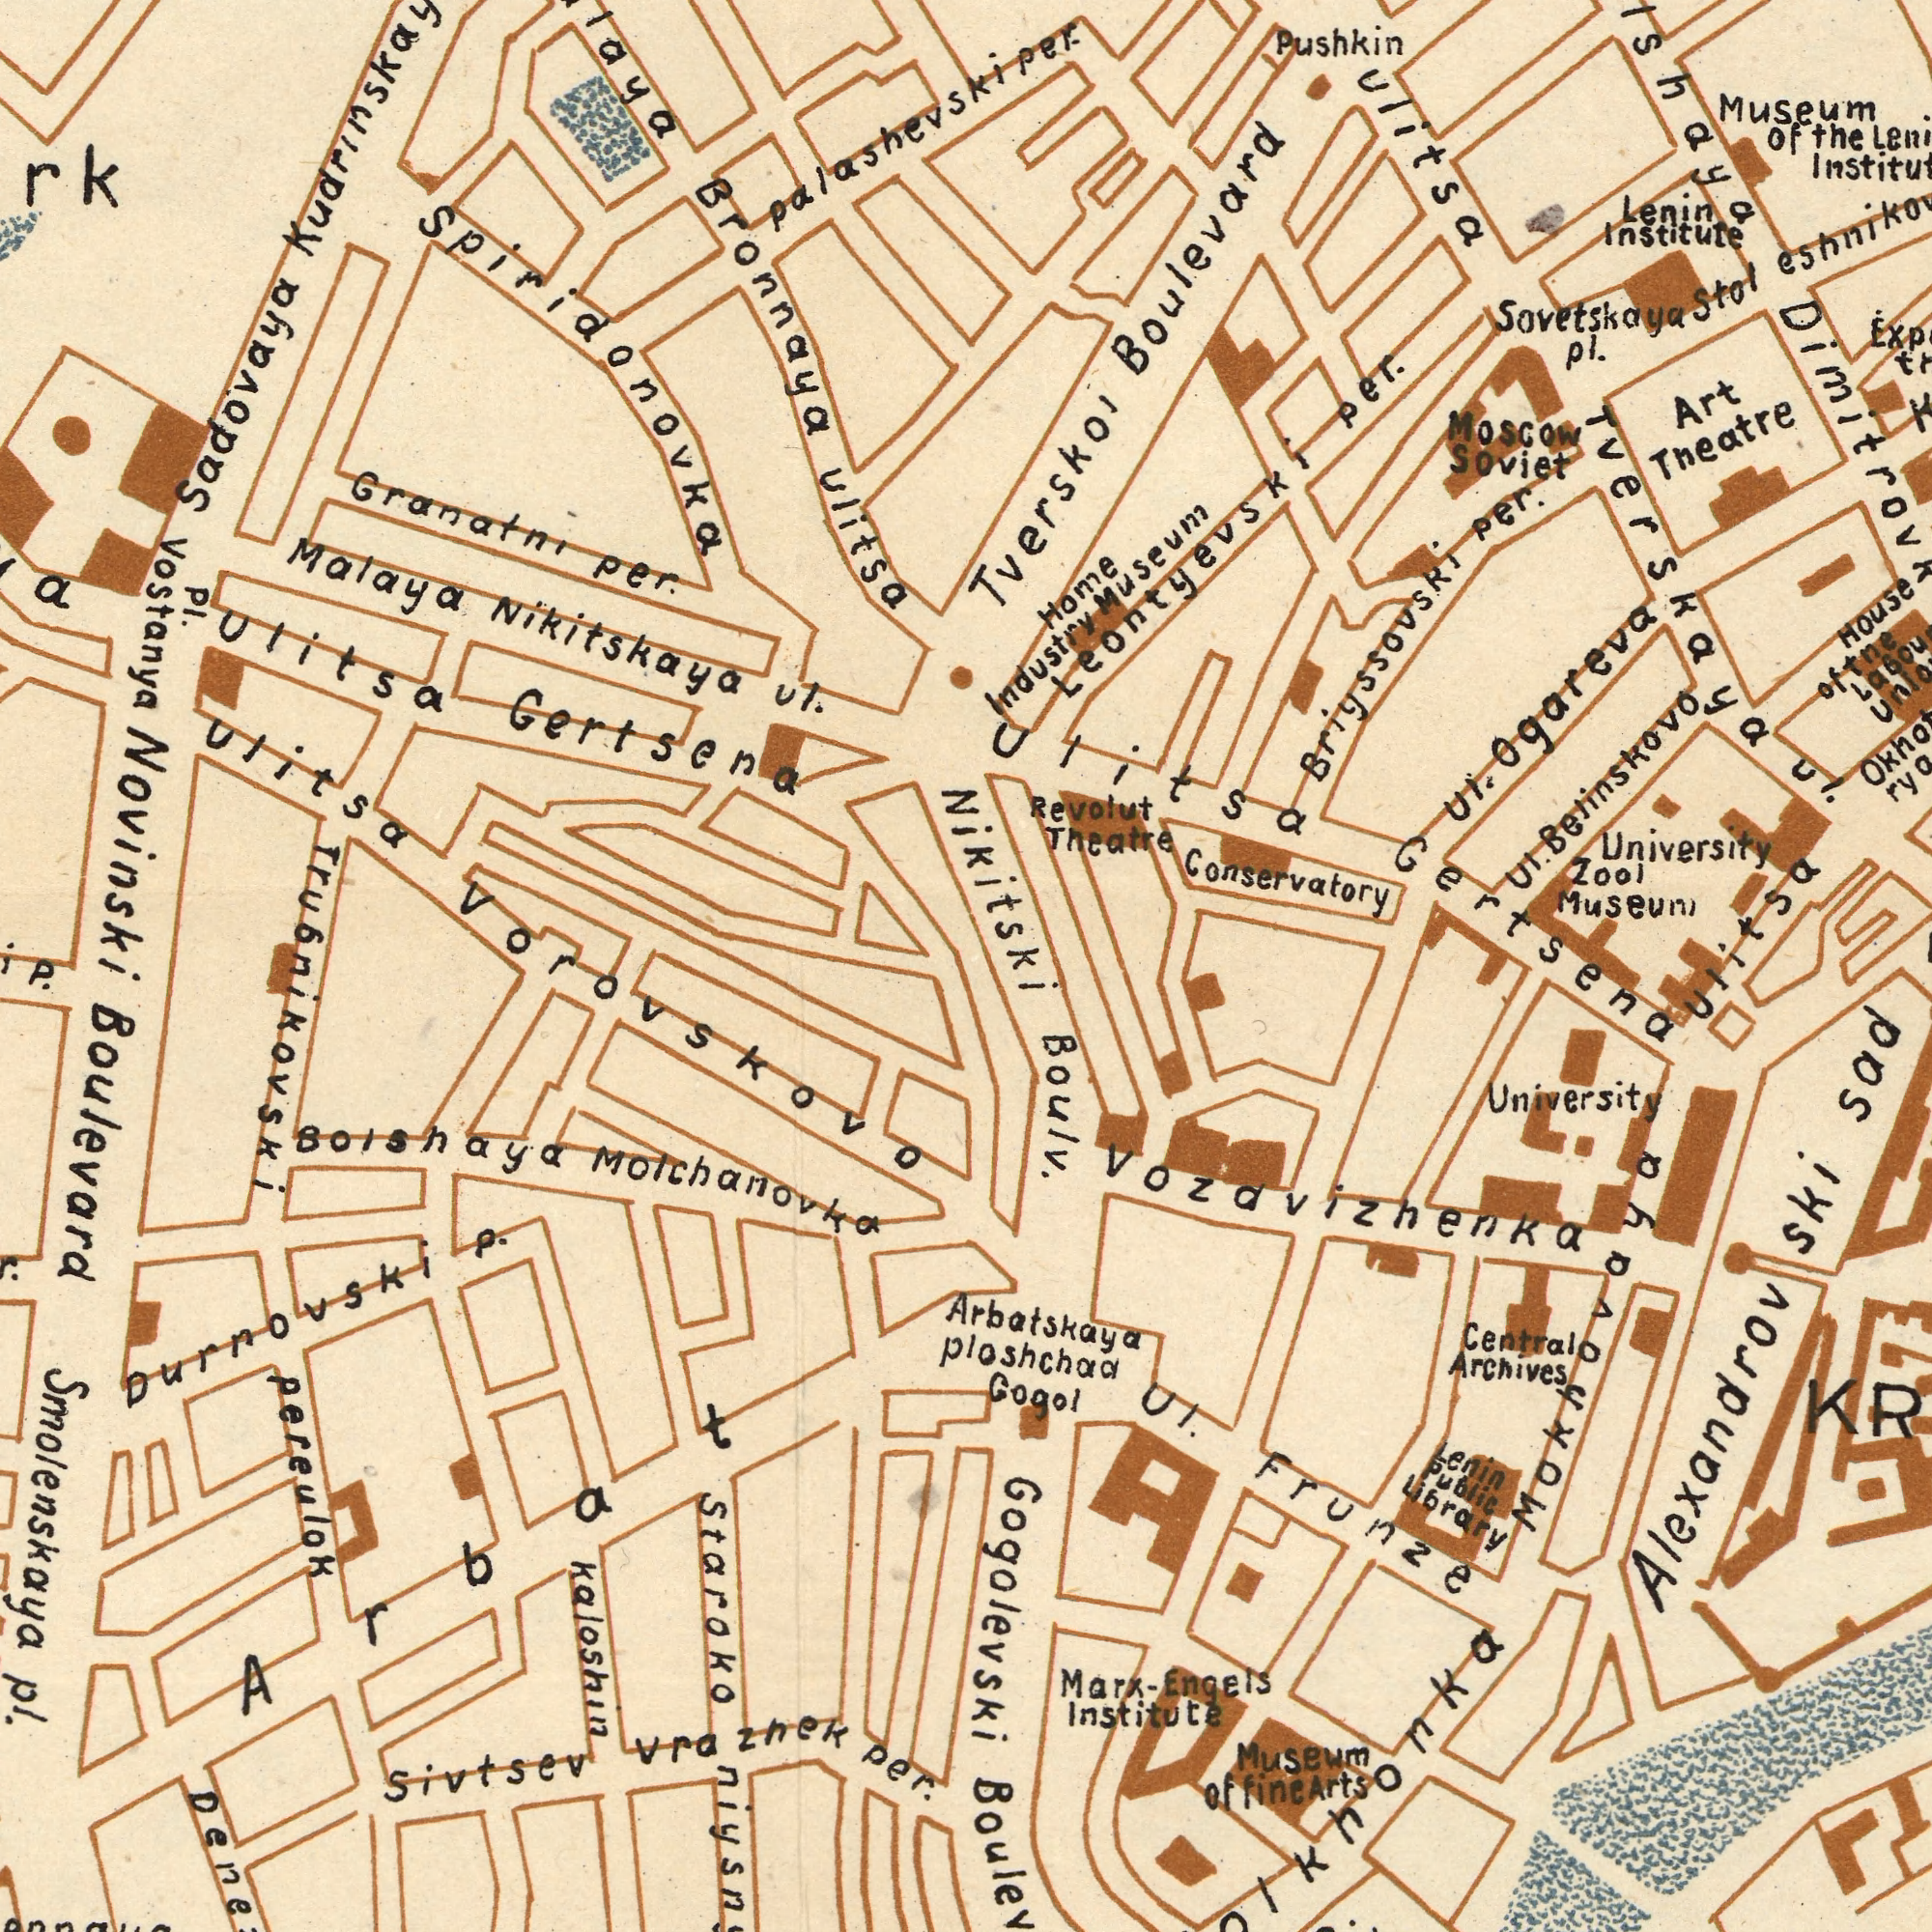What text appears in the bottom-left area of the image? Staroko Pereulok Sivtsev Durrovski Per. Kaloshin Pl. Vra Boulevard Zhek Bolshaya P. Smolenskaya Molchanovka Vorovskovo Trubnikovski Arbat What text appears in the bottom-right area of the image? Gertsena Ploshchaa University Central Arbatskaya Institute Frunze Alexandrov Gogol Archives Engels Gogolevski Marx- ul. Ski Vozdvizhenka Sad Boulv. Ulitsa Lenin Pubilc Libray Museum Of Fine Arts Mokhovaya What text can you see in the top-right section? Conservatory Institute University Theatre Museum Moscow Ogareva Soviet House Per. Home Lenin Briyssovski ul. Boulevard Per. Pushkin Zool Tverskoi Museum Museum ulitsa Theatre Belinskovo ul. Revolut of ul. Industry Art the Leontyevski Sovetskaya Pl. Tverskaya of the Nikitski Ulitsa Per. Stol What text can you see in the top-left section? Ulitsa Bronnaya Malaya Gertsena Per. Novinski Ulitsa Granatni ul. Sadovaya Spiridonovka Nikitskaya ###rk Palashevski Pl. Vostanya Ulitsa 